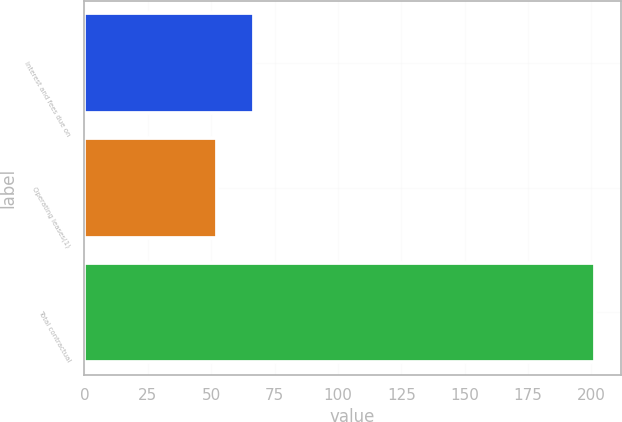Convert chart. <chart><loc_0><loc_0><loc_500><loc_500><bar_chart><fcel>Interest and fees due on<fcel>Operating leases(1)<fcel>Total contractual<nl><fcel>67.04<fcel>52.1<fcel>201.5<nl></chart> 